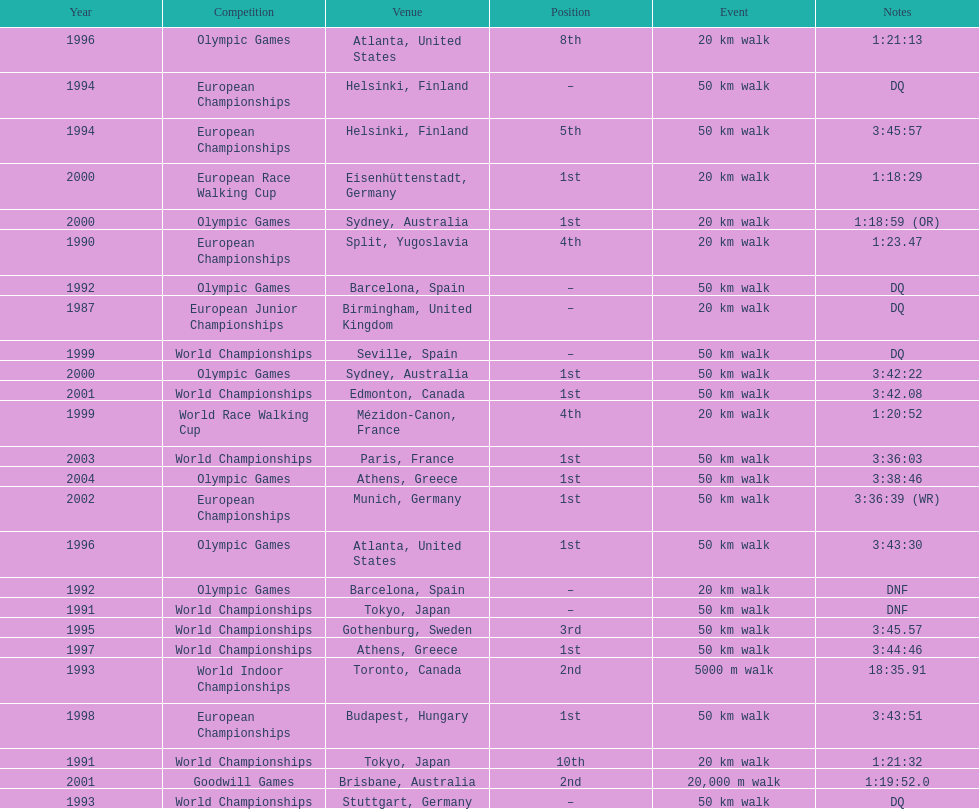How many times was korzeniowski disqualified from a competition? 5. 